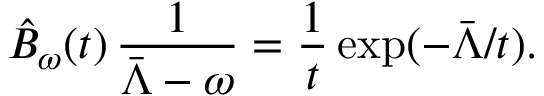Convert formula to latex. <formula><loc_0><loc_0><loc_500><loc_500>\hat { B } _ { \omega } ( t ) \, \frac { 1 } { \bar { \Lambda } - \omega } = \frac { 1 } { t } \exp ( - \bar { \Lambda } / t ) .</formula> 